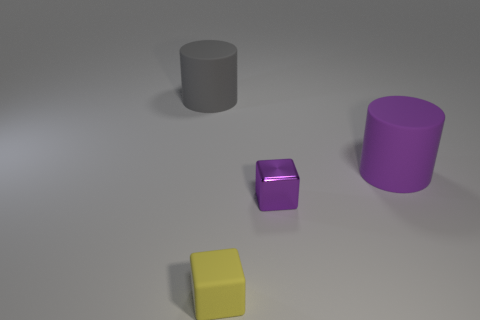Add 2 big brown rubber objects. How many objects exist? 6 Subtract 0 blue spheres. How many objects are left? 4 Subtract all large yellow matte cylinders. Subtract all gray cylinders. How many objects are left? 3 Add 4 tiny rubber things. How many tiny rubber things are left? 5 Add 1 yellow things. How many yellow things exist? 2 